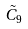Convert formula to latex. <formula><loc_0><loc_0><loc_500><loc_500>\tilde { C } _ { 9 }</formula> 